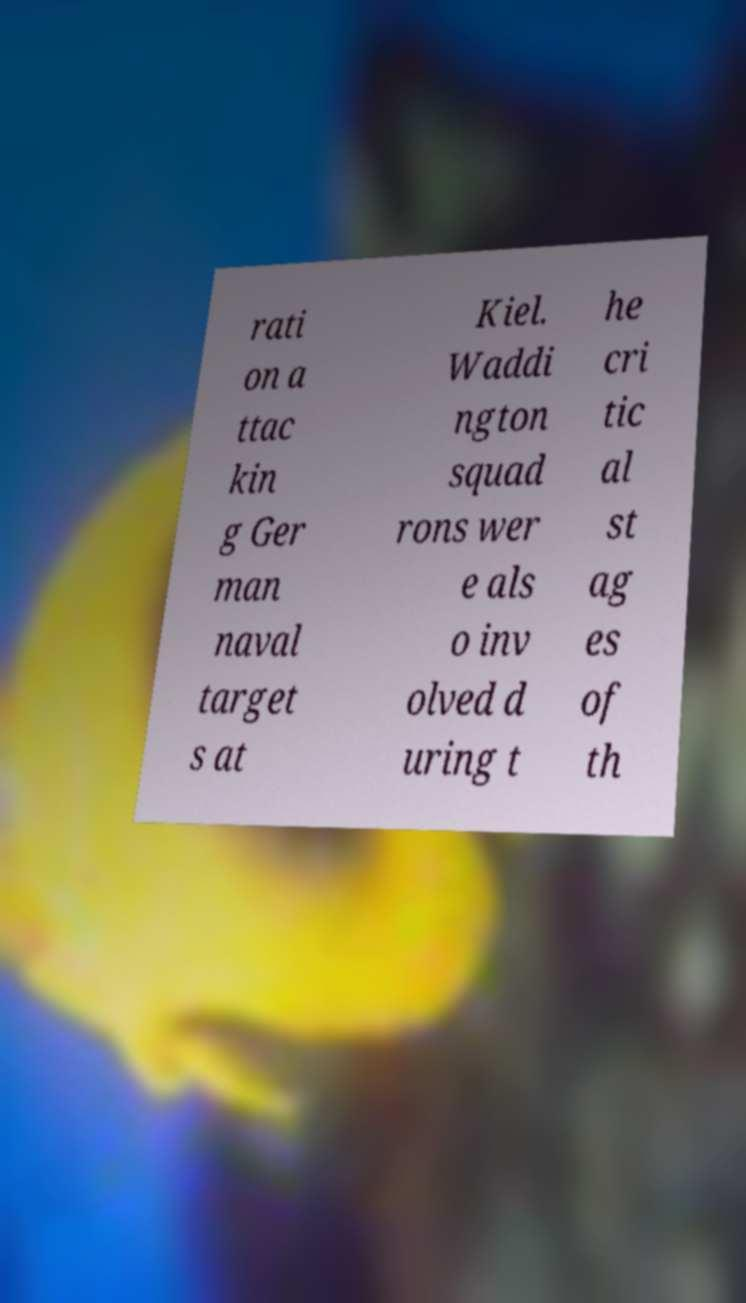Could you extract and type out the text from this image? rati on a ttac kin g Ger man naval target s at Kiel. Waddi ngton squad rons wer e als o inv olved d uring t he cri tic al st ag es of th 